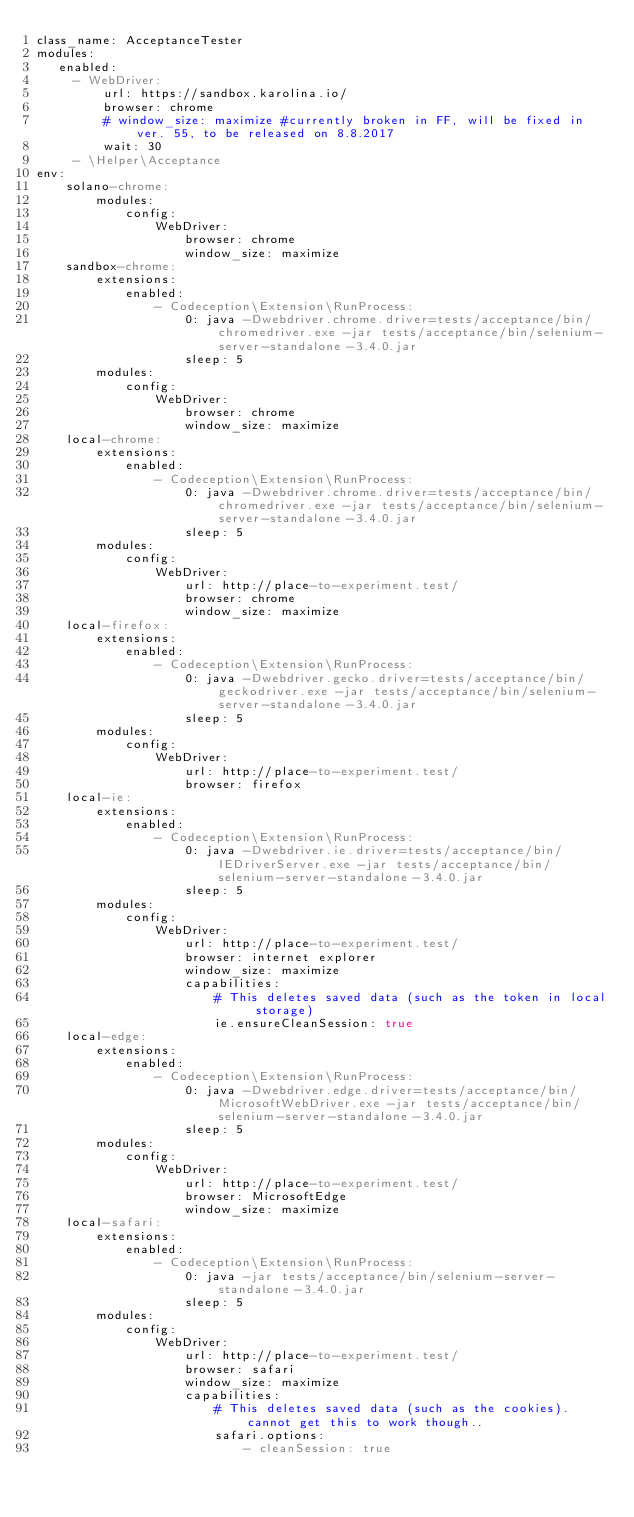Convert code to text. <code><loc_0><loc_0><loc_500><loc_500><_YAML_>class_name: AcceptanceTester
modules:
   enabled:
     - WebDriver:
         url: https://sandbox.karolina.io/
         browser: chrome
         # window_size: maximize #currently broken in FF, will be fixed in ver. 55, to be released on 8.8.2017
         wait: 30
     - \Helper\Acceptance
env:
    solano-chrome:
        modules:
            config:
                WebDriver:
                    browser: chrome
                    window_size: maximize
    sandbox-chrome:
        extensions:
            enabled:
                - Codeception\Extension\RunProcess:
                    0: java -Dwebdriver.chrome.driver=tests/acceptance/bin/chromedriver.exe -jar tests/acceptance/bin/selenium-server-standalone-3.4.0.jar
                    sleep: 5
        modules:
            config:
                WebDriver:
                    browser: chrome
                    window_size: maximize
    local-chrome:
        extensions:
            enabled:
                - Codeception\Extension\RunProcess:
                    0: java -Dwebdriver.chrome.driver=tests/acceptance/bin/chromedriver.exe -jar tests/acceptance/bin/selenium-server-standalone-3.4.0.jar
                    sleep: 5
        modules:
            config:
                WebDriver:
                    url: http://place-to-experiment.test/
                    browser: chrome
                    window_size: maximize
    local-firefox:
        extensions:
            enabled:
                - Codeception\Extension\RunProcess:
                    0: java -Dwebdriver.gecko.driver=tests/acceptance/bin/geckodriver.exe -jar tests/acceptance/bin/selenium-server-standalone-3.4.0.jar
                    sleep: 5
        modules:
            config:
                WebDriver:
                    url: http://place-to-experiment.test/
                    browser: firefox
    local-ie:
        extensions:
            enabled:
                - Codeception\Extension\RunProcess:
                    0: java -Dwebdriver.ie.driver=tests/acceptance/bin/IEDriverServer.exe -jar tests/acceptance/bin/selenium-server-standalone-3.4.0.jar
                    sleep: 5
        modules:
            config:
                WebDriver:
                    url: http://place-to-experiment.test/
                    browser: internet explorer
                    window_size: maximize
                    capabilities:
                        # This deletes saved data (such as the token in local storage)
                        ie.ensureCleanSession: true
    local-edge:
        extensions:
            enabled:
                - Codeception\Extension\RunProcess:
                    0: java -Dwebdriver.edge.driver=tests/acceptance/bin/MicrosoftWebDriver.exe -jar tests/acceptance/bin/selenium-server-standalone-3.4.0.jar
                    sleep: 5
        modules:
            config:
                WebDriver:
                    url: http://place-to-experiment.test/
                    browser: MicrosoftEdge
                    window_size: maximize
    local-safari:
        extensions:
            enabled:
                - Codeception\Extension\RunProcess:
                    0: java -jar tests/acceptance/bin/selenium-server-standalone-3.4.0.jar
                    sleep: 5
        modules:
            config:
                WebDriver:
                    url: http://place-to-experiment.test/
                    browser: safari
                    window_size: maximize
                    capabilities:
                        # This deletes saved data (such as the cookies). cannot get this to work though..
                        safari.options:
                            - cleanSession: true
</code> 